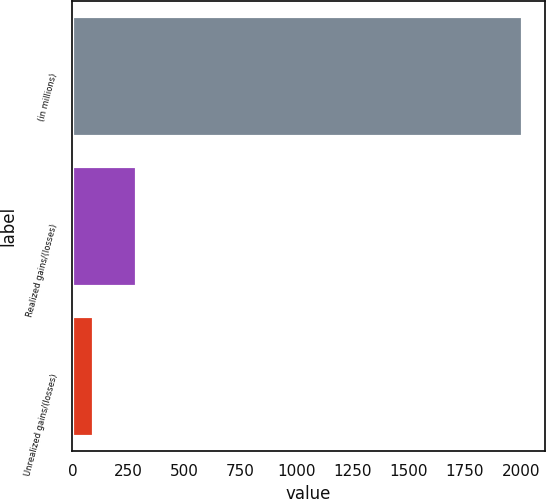Convert chart to OTSL. <chart><loc_0><loc_0><loc_500><loc_500><bar_chart><fcel>(in millions)<fcel>Realized gains/(losses)<fcel>Unrealized gains/(losses)<nl><fcel>2007<fcel>285.3<fcel>94<nl></chart> 